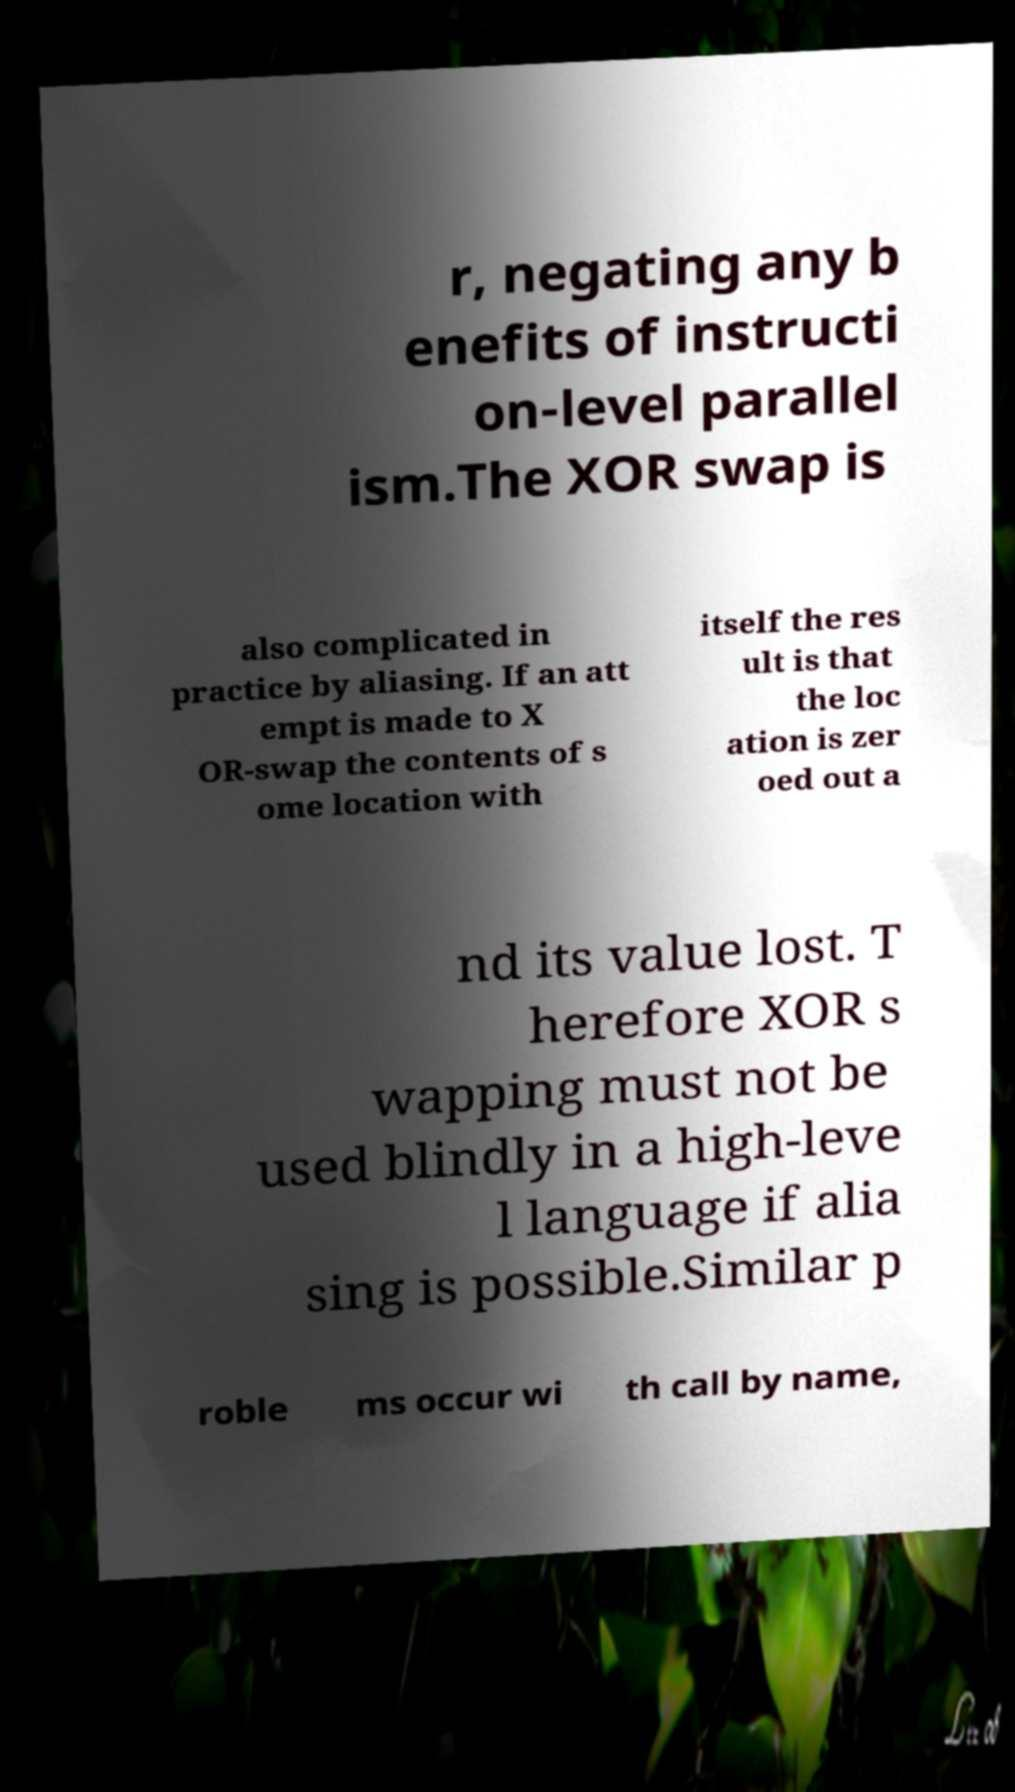Could you extract and type out the text from this image? r, negating any b enefits of instructi on-level parallel ism.The XOR swap is also complicated in practice by aliasing. If an att empt is made to X OR-swap the contents of s ome location with itself the res ult is that the loc ation is zer oed out a nd its value lost. T herefore XOR s wapping must not be used blindly in a high-leve l language if alia sing is possible.Similar p roble ms occur wi th call by name, 